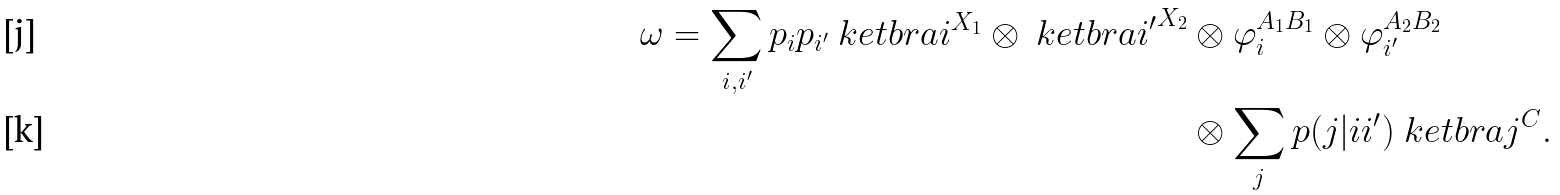Convert formula to latex. <formula><loc_0><loc_0><loc_500><loc_500>\omega = \sum _ { i , i ^ { \prime } } p _ { i } p _ { i ^ { \prime } } \ k e t b r a { i } ^ { X _ { 1 } } \otimes \ k e t b r a { i ^ { \prime } } ^ { X _ { 2 } } & \otimes \varphi _ { i } ^ { A _ { 1 } B _ { 1 } } \otimes \varphi _ { i ^ { \prime } } ^ { A _ { 2 } B _ { 2 } } \\ & \otimes \sum _ { j } p ( j | i i ^ { \prime } ) \ k e t b r a { j } ^ { C } .</formula> 